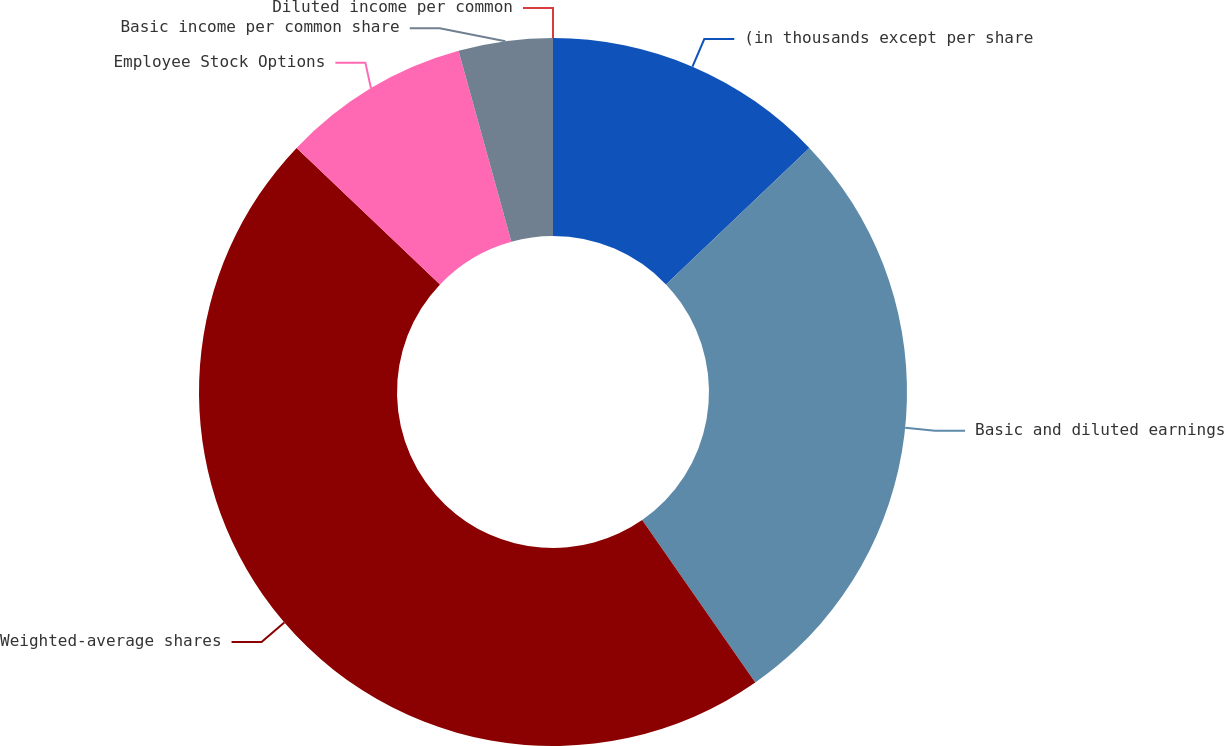<chart> <loc_0><loc_0><loc_500><loc_500><pie_chart><fcel>(in thousands except per share<fcel>Basic and diluted earnings<fcel>Weighted-average shares<fcel>Employee Stock Options<fcel>Basic income per common share<fcel>Diluted income per common<nl><fcel>12.89%<fcel>27.43%<fcel>46.79%<fcel>8.59%<fcel>4.3%<fcel>0.0%<nl></chart> 